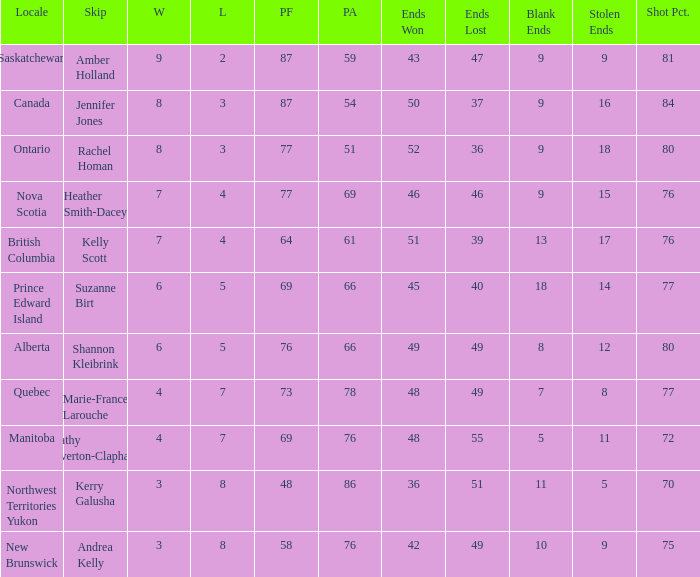If the skip is Kelly Scott, what is the PF total number? 1.0. 